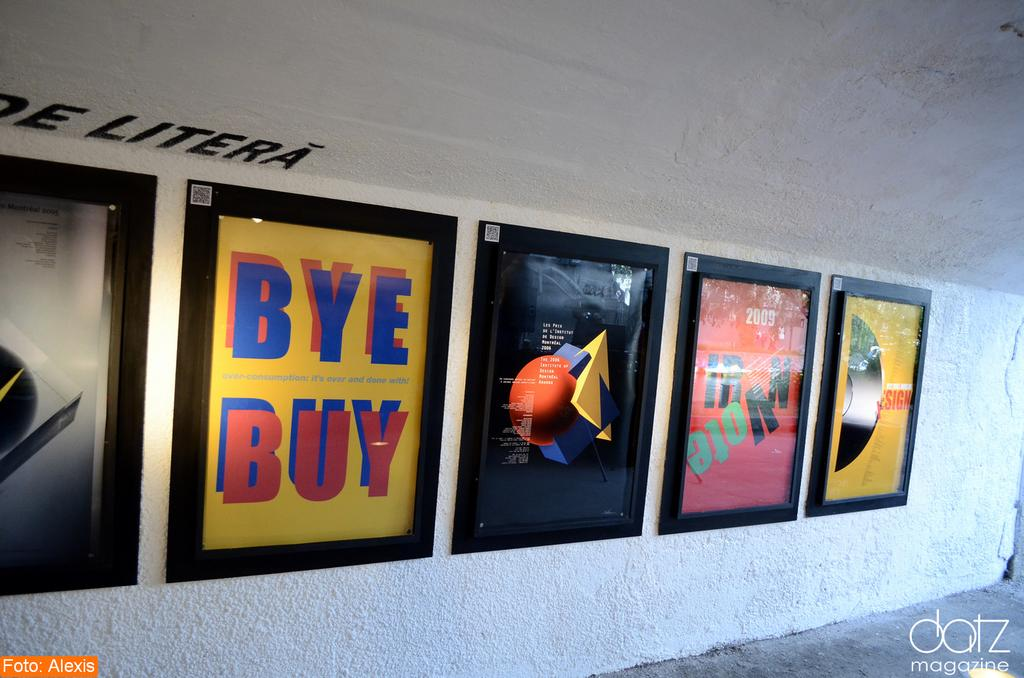<image>
Describe the image concisely. A series of posters, one of which says 'BYE BUY'. 